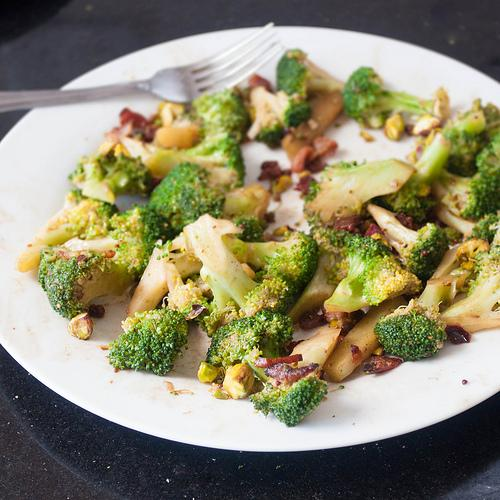Briefly describe the placement of the silver fork in relation to the white plate. The silver fork is located on the round white plate, positioned near the top left corner. Is there any object in the image that stands out from the rest? Yes, the silver fork stands out from the rest of the objects, as it is the only non-food item in the image. Can you please count the number of broccoli florets in the image? There are eight broccoli florets on different plates in the image. Describe the type of reasoning required to deduce if there are any non-edible objects in the image. To identify any non-edible objects in the image, one must analyze and discern between food items like broccoli and nuts, and other objects such as plates, forks or tables, which are not meant for consumption. What is the color of the table in the image? The table in the image is black. In the image, are there any vegetables other than broccoli? No, the only vegetables visible in the image are broccoli florets. Assess the quality of the image in terms of clarity and presentation. The image quality seems decent with clear object presentations, showcasing the plates, broccoli florets, and silver fork without any significant blur or distortion. Can you identify any object interactions in the image? The silver fork interacts with the plate, as it is placed on top of it. Other than that, the broccoli florets and nuts are displayed on plates separately. Describe the sentiment or mood of the image. The image has a neutral sentiment, as it displays various plates with broccoli florets and a silver fork without any elements to evoke a specific emotion. Identify and describe the primary objects present in the image. The image contains a silver fork on a round white plate, broccoli florets on various white plates, pieces of nuts, and a black table. Observe the half-filled glass of water standing next to the plate on the black table. No, it's not mentioned in the image. 